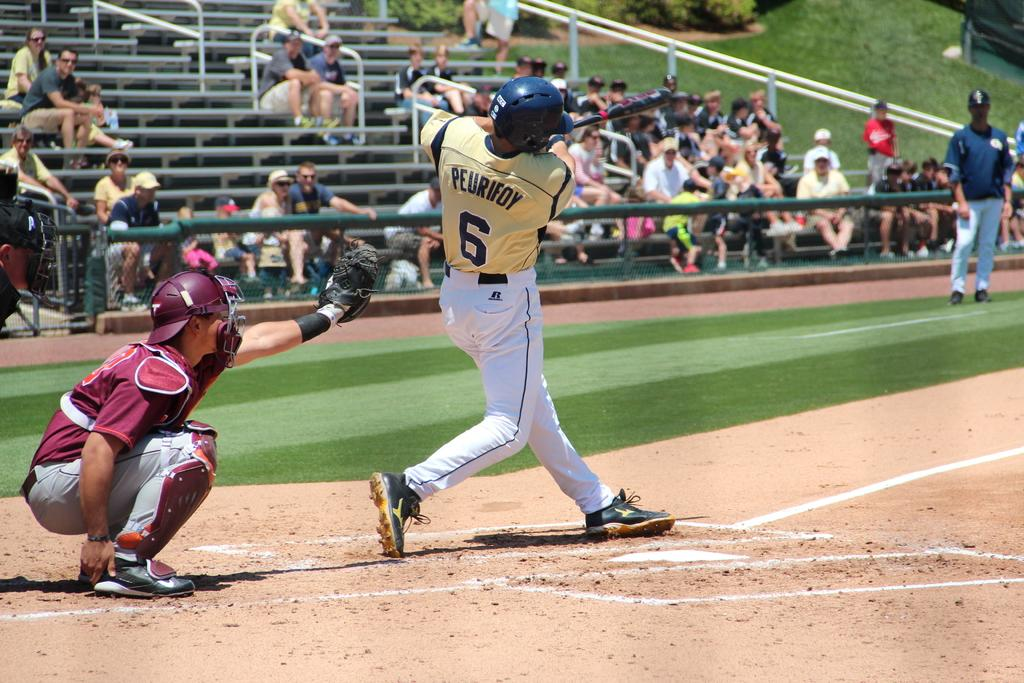<image>
Summarize the visual content of the image. Baseball Game with the batters shirt saying Peurifoy 6. 